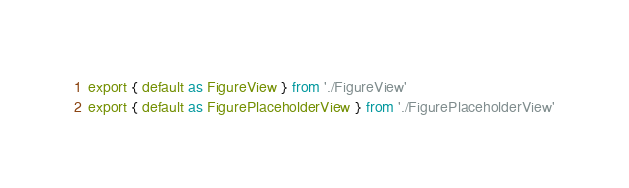<code> <loc_0><loc_0><loc_500><loc_500><_TypeScript_>export { default as FigureView } from './FigureView'
export { default as FigurePlaceholderView } from './FigurePlaceholderView'
</code> 